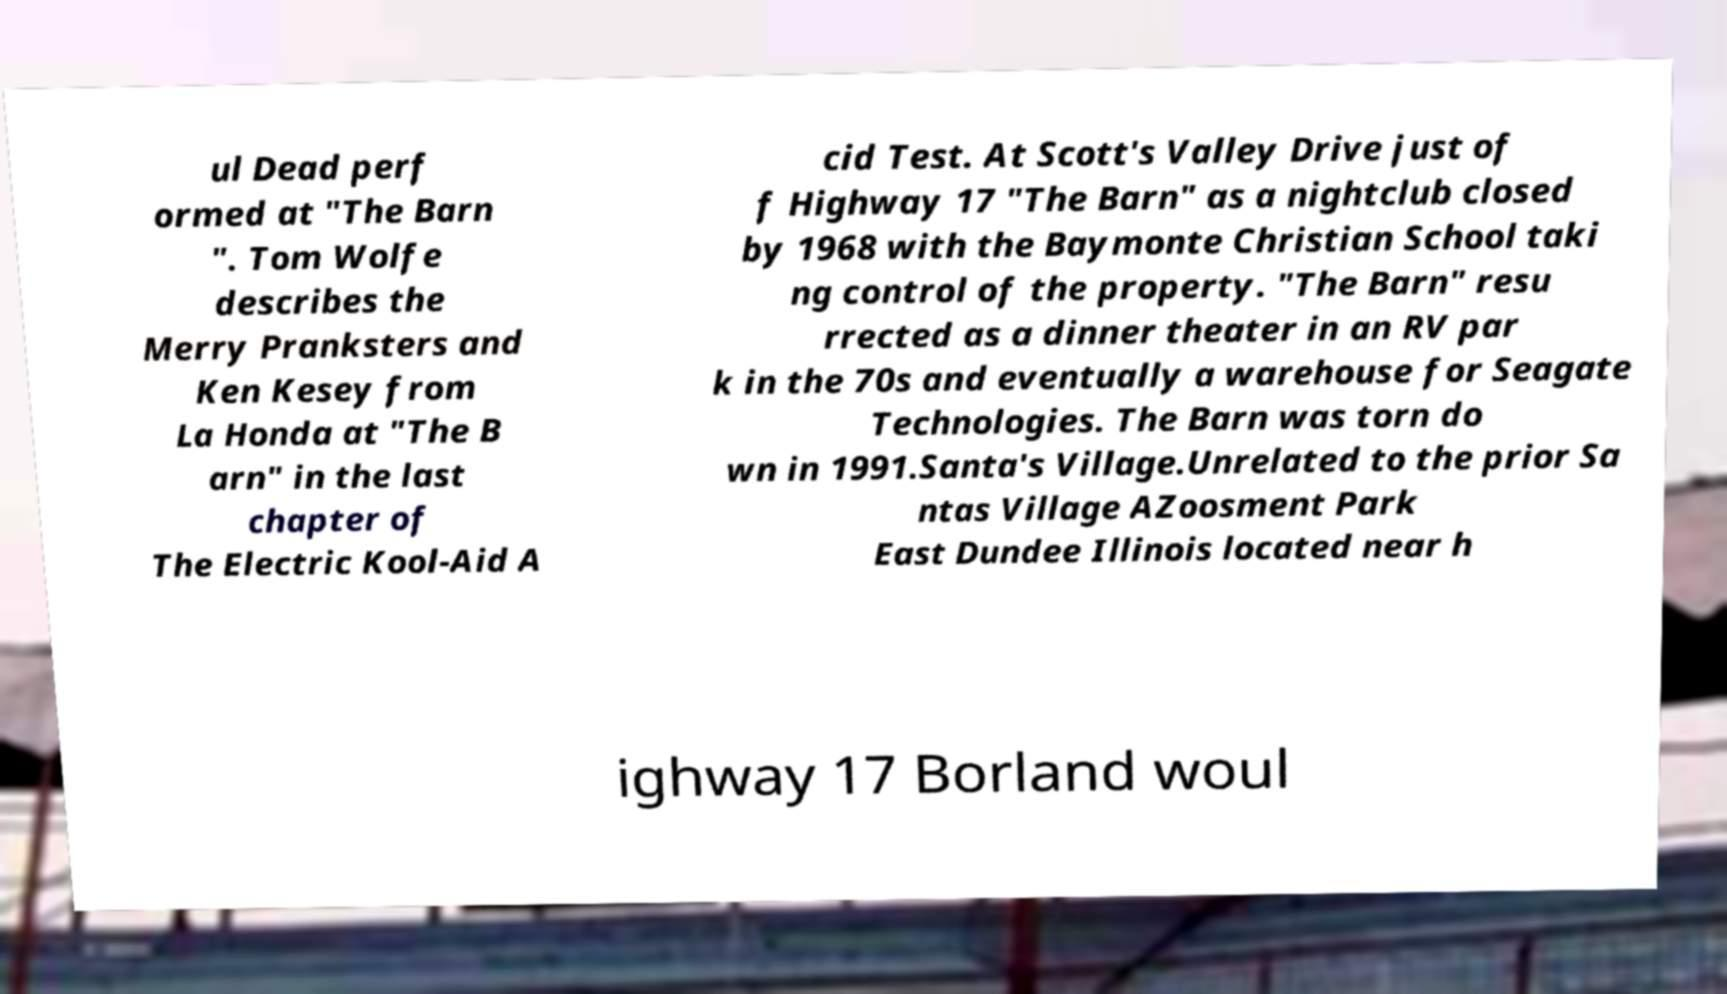For documentation purposes, I need the text within this image transcribed. Could you provide that? ul Dead perf ormed at "The Barn ". Tom Wolfe describes the Merry Pranksters and Ken Kesey from La Honda at "The B arn" in the last chapter of The Electric Kool-Aid A cid Test. At Scott's Valley Drive just of f Highway 17 "The Barn" as a nightclub closed by 1968 with the Baymonte Christian School taki ng control of the property. "The Barn" resu rrected as a dinner theater in an RV par k in the 70s and eventually a warehouse for Seagate Technologies. The Barn was torn do wn in 1991.Santa's Village.Unrelated to the prior Sa ntas Village AZoosment Park East Dundee Illinois located near h ighway 17 Borland woul 